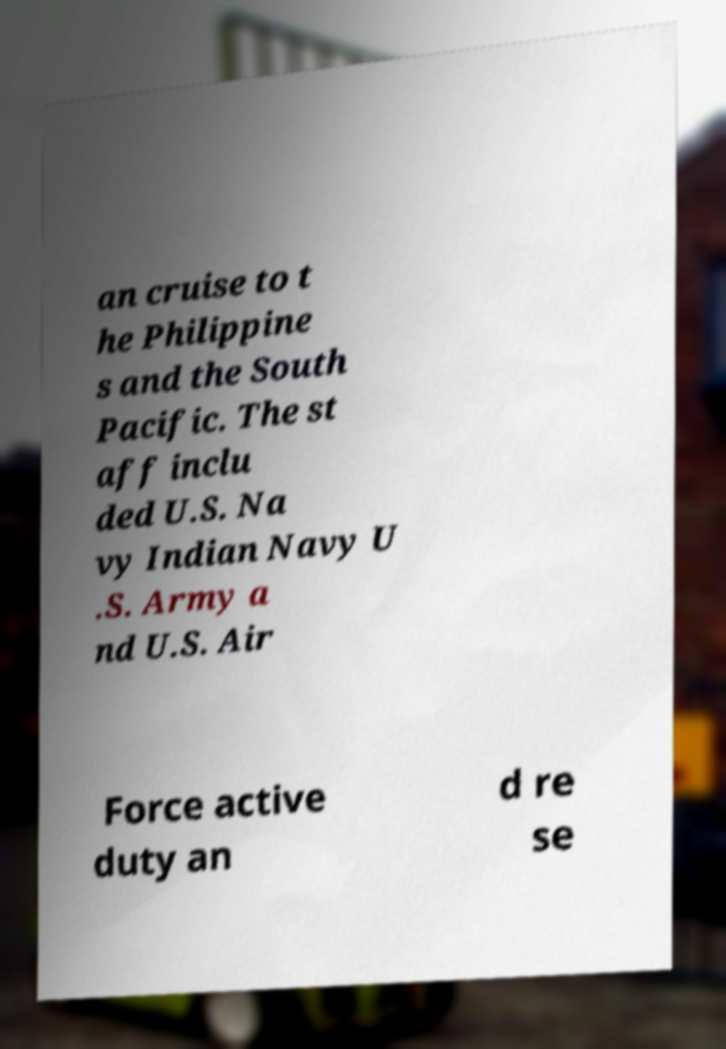What messages or text are displayed in this image? I need them in a readable, typed format. an cruise to t he Philippine s and the South Pacific. The st aff inclu ded U.S. Na vy Indian Navy U .S. Army a nd U.S. Air Force active duty an d re se 